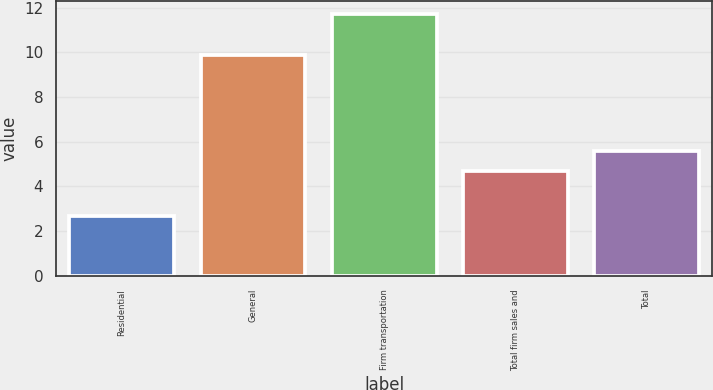<chart> <loc_0><loc_0><loc_500><loc_500><bar_chart><fcel>Residential<fcel>General<fcel>Firm transportation<fcel>Total firm sales and<fcel>Total<nl><fcel>2.7<fcel>9.9<fcel>11.7<fcel>4.7<fcel>5.6<nl></chart> 